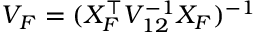Convert formula to latex. <formula><loc_0><loc_0><loc_500><loc_500>V _ { F } = ( X _ { F } ^ { \top } V _ { 1 2 } ^ { - 1 } X _ { F } ) ^ { - 1 }</formula> 